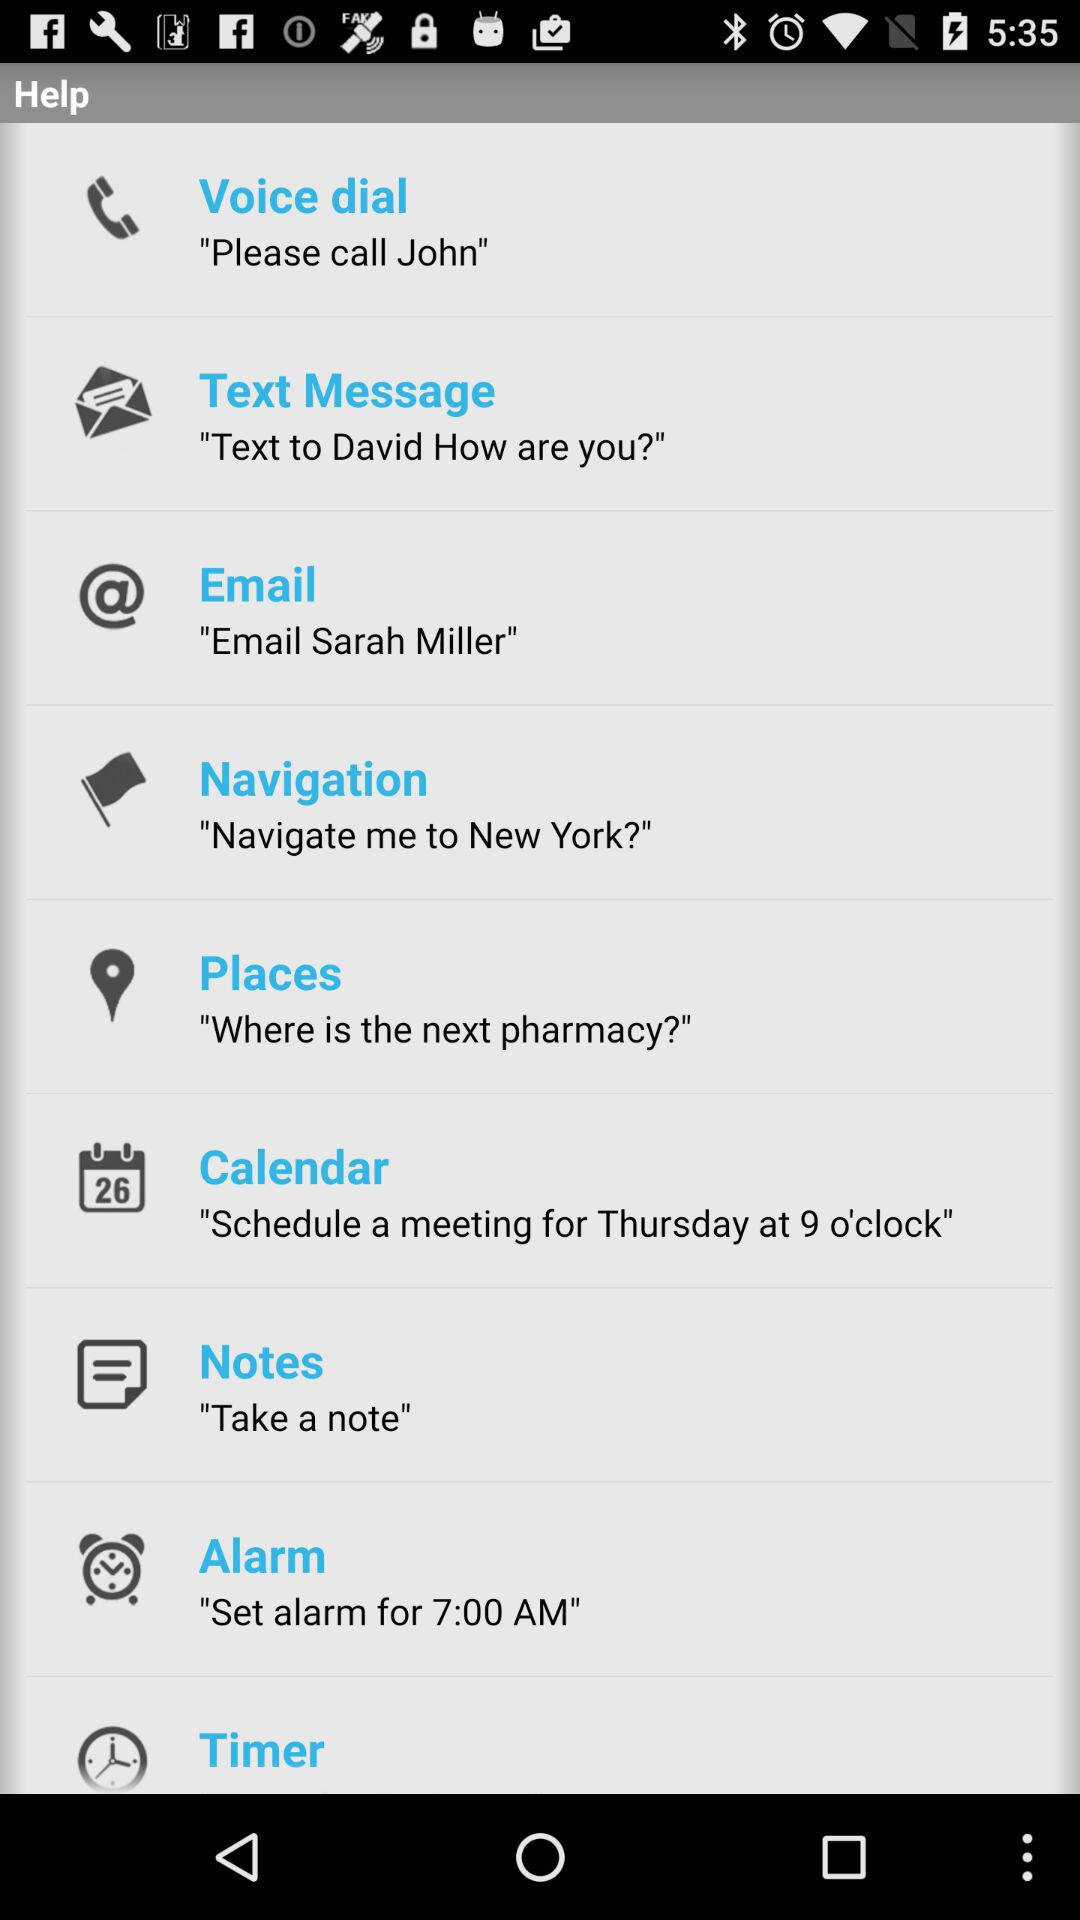What is the suggested day for scheduling a meeting? The day is Thursday. 